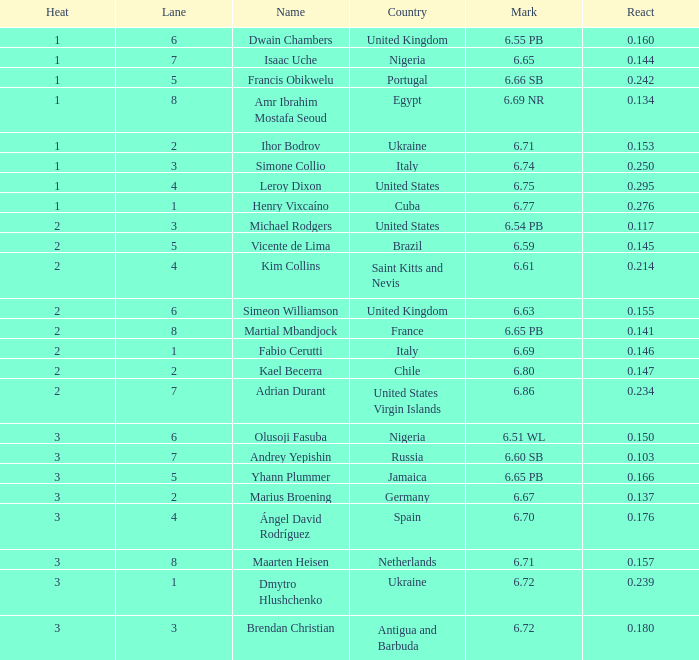Write the full table. {'header': ['Heat', 'Lane', 'Name', 'Country', 'Mark', 'React'], 'rows': [['1', '6', 'Dwain Chambers', 'United Kingdom', '6.55 PB', '0.160'], ['1', '7', 'Isaac Uche', 'Nigeria', '6.65', '0.144'], ['1', '5', 'Francis Obikwelu', 'Portugal', '6.66 SB', '0.242'], ['1', '8', 'Amr Ibrahim Mostafa Seoud', 'Egypt', '6.69 NR', '0.134'], ['1', '2', 'Ihor Bodrov', 'Ukraine', '6.71', '0.153'], ['1', '3', 'Simone Collio', 'Italy', '6.74', '0.250'], ['1', '4', 'Leroy Dixon', 'United States', '6.75', '0.295'], ['1', '1', 'Henry Vixcaíno', 'Cuba', '6.77', '0.276'], ['2', '3', 'Michael Rodgers', 'United States', '6.54 PB', '0.117'], ['2', '5', 'Vicente de Lima', 'Brazil', '6.59', '0.145'], ['2', '4', 'Kim Collins', 'Saint Kitts and Nevis', '6.61', '0.214'], ['2', '6', 'Simeon Williamson', 'United Kingdom', '6.63', '0.155'], ['2', '8', 'Martial Mbandjock', 'France', '6.65 PB', '0.141'], ['2', '1', 'Fabio Cerutti', 'Italy', '6.69', '0.146'], ['2', '2', 'Kael Becerra', 'Chile', '6.80', '0.147'], ['2', '7', 'Adrian Durant', 'United States Virgin Islands', '6.86', '0.234'], ['3', '6', 'Olusoji Fasuba', 'Nigeria', '6.51 WL', '0.150'], ['3', '7', 'Andrey Yepishin', 'Russia', '6.60 SB', '0.103'], ['3', '5', 'Yhann Plummer', 'Jamaica', '6.65 PB', '0.166'], ['3', '2', 'Marius Broening', 'Germany', '6.67', '0.137'], ['3', '4', 'Ángel David Rodríguez', 'Spain', '6.70', '0.176'], ['3', '8', 'Maarten Heisen', 'Netherlands', '6.71', '0.157'], ['3', '1', 'Dmytro Hlushchenko', 'Ukraine', '6.72', '0.239'], ['3', '3', 'Brendan Christian', 'Antigua and Barbuda', '6.72', '0.180']]} What is Mark, when Name is Dmytro Hlushchenko? 6.72. 